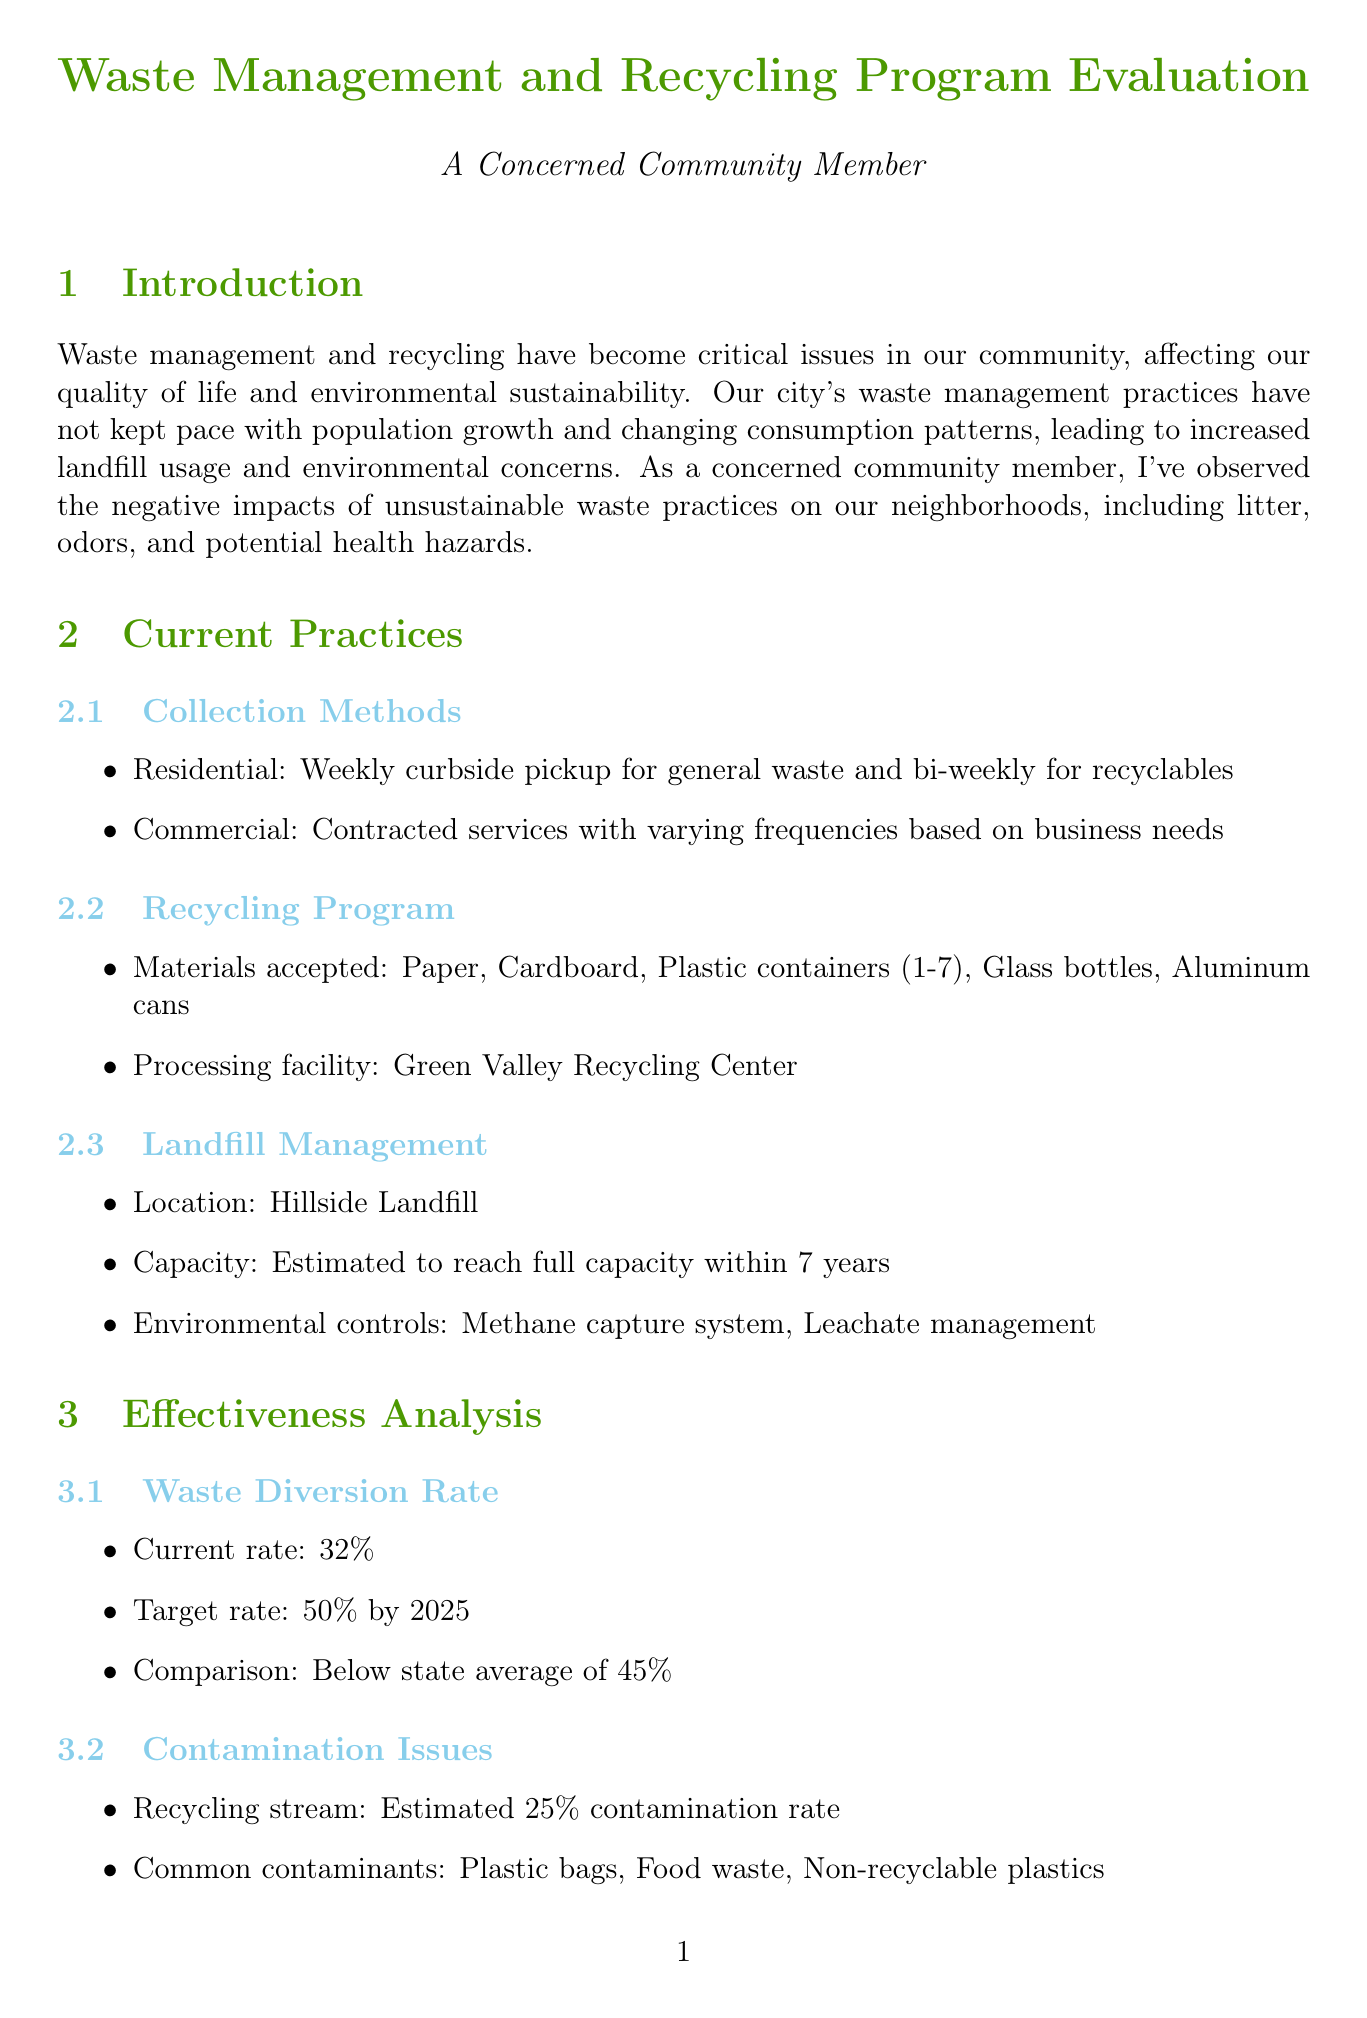What is the current waste diversion rate? The current waste diversion rate is provided in the effectiveness analysis section, stating that it is 32%.
Answer: 32% What is the target waste diversion rate by 2025? The target waste diversion rate is outlined in the effectiveness analysis, indicating it is aimed to be 50% by 2025.
Answer: 50% What is the participation rate for recycling in multi-unit dwellings? The participation rate for recycling in multi-unit dwellings can be found in the participation rates section, which states it is 45%.
Answer: 45% What are the main concerns from the community survey feedback? The main concerns are listed in the community feedback section, indicating they include limited recycling options, infrequent bulky item pickup, and lack of composting program.
Answer: Limited recycling options, Infrequent bulky item pickup, Lack of composting program How many participants were there in the annual recycling drive in 2022? The number of participants in the annual recycling drive is specified in the community events section, which notes there were 1,200 participants in 2022.
Answer: 1,200 What is one of the proposed components for the 'Recycle Right' campaign? The proposed components of the 'Recycle Right' campaign include school programs as mentioned in the recommendations section.
Answer: School programs What is the estimated capacity timeframe for Hillside Landfill? The estimated capacity timeframe for Hillside Landfill is indicated in the landfill management section, stating it will reach full capacity within 7 years.
Answer: 7 years What is the estimated contamination rate of the recycling stream? The estimated contamination rate of the recycling stream is detailed in the effectiveness analysis section, stating it is 25%.
Answer: 25% What is the proposed action for a residential food waste composting program? The proposed action for a residential food waste composting program is specified in the program expansion recommendations, indicating a pilot program in partnership with City Gardens Project.
Answer: Pilot a residential food waste composting program with City Gardens Project 